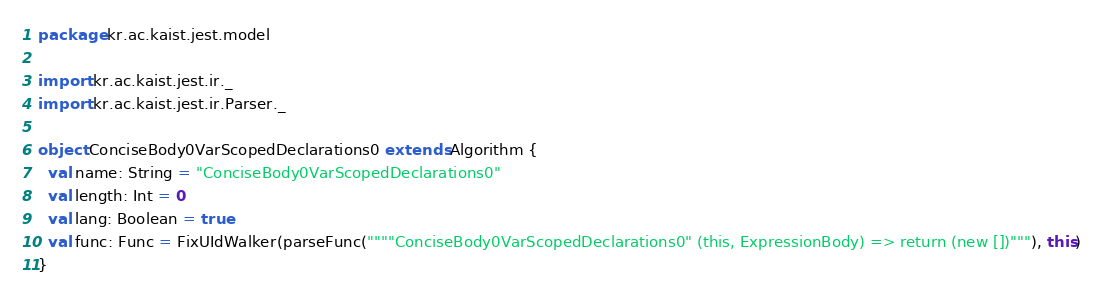<code> <loc_0><loc_0><loc_500><loc_500><_Scala_>package kr.ac.kaist.jest.model

import kr.ac.kaist.jest.ir._
import kr.ac.kaist.jest.ir.Parser._

object ConciseBody0VarScopedDeclarations0 extends Algorithm {
  val name: String = "ConciseBody0VarScopedDeclarations0"
  val length: Int = 0
  val lang: Boolean = true
  val func: Func = FixUIdWalker(parseFunc(""""ConciseBody0VarScopedDeclarations0" (this, ExpressionBody) => return (new [])"""), this)
}
</code> 